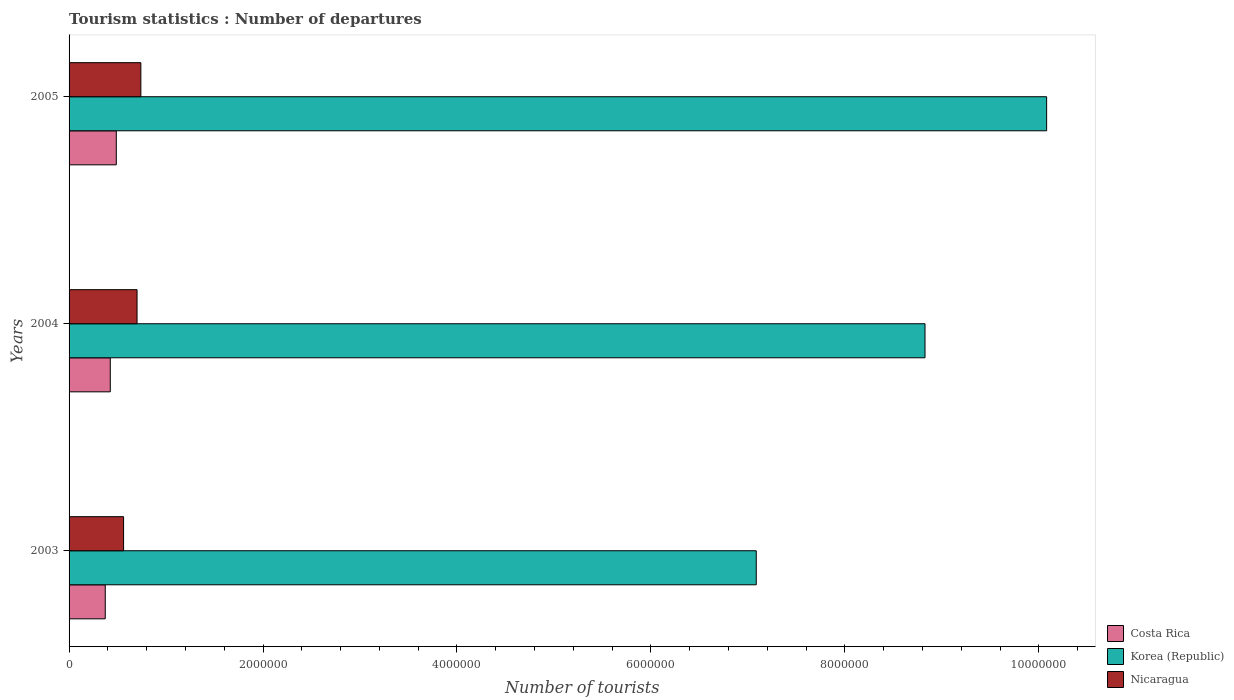Are the number of bars per tick equal to the number of legend labels?
Your response must be concise. Yes. How many bars are there on the 3rd tick from the top?
Your response must be concise. 3. How many bars are there on the 1st tick from the bottom?
Your response must be concise. 3. What is the number of tourist departures in Nicaragua in 2003?
Your answer should be very brief. 5.62e+05. Across all years, what is the maximum number of tourist departures in Costa Rica?
Provide a short and direct response. 4.87e+05. Across all years, what is the minimum number of tourist departures in Costa Rica?
Provide a short and direct response. 3.73e+05. In which year was the number of tourist departures in Costa Rica maximum?
Make the answer very short. 2005. In which year was the number of tourist departures in Nicaragua minimum?
Your answer should be compact. 2003. What is the total number of tourist departures in Nicaragua in the graph?
Ensure brevity in your answer.  2.00e+06. What is the difference between the number of tourist departures in Korea (Republic) in 2003 and that in 2005?
Make the answer very short. -2.99e+06. What is the difference between the number of tourist departures in Nicaragua in 2004 and the number of tourist departures in Korea (Republic) in 2003?
Offer a terse response. -6.38e+06. What is the average number of tourist departures in Costa Rica per year?
Ensure brevity in your answer.  4.28e+05. In the year 2005, what is the difference between the number of tourist departures in Nicaragua and number of tourist departures in Korea (Republic)?
Make the answer very short. -9.34e+06. In how many years, is the number of tourist departures in Costa Rica greater than 8800000 ?
Provide a succinct answer. 0. What is the ratio of the number of tourist departures in Nicaragua in 2003 to that in 2004?
Give a very brief answer. 0.8. What is the difference between the highest and the second highest number of tourist departures in Costa Rica?
Provide a short and direct response. 6.20e+04. What is the difference between the highest and the lowest number of tourist departures in Nicaragua?
Your answer should be very brief. 1.78e+05. In how many years, is the number of tourist departures in Korea (Republic) greater than the average number of tourist departures in Korea (Republic) taken over all years?
Give a very brief answer. 2. Is the sum of the number of tourist departures in Korea (Republic) in 2003 and 2005 greater than the maximum number of tourist departures in Nicaragua across all years?
Your answer should be compact. Yes. Is it the case that in every year, the sum of the number of tourist departures in Nicaragua and number of tourist departures in Korea (Republic) is greater than the number of tourist departures in Costa Rica?
Your answer should be very brief. Yes. Are all the bars in the graph horizontal?
Your answer should be very brief. Yes. How many years are there in the graph?
Keep it short and to the point. 3. What is the difference between two consecutive major ticks on the X-axis?
Offer a terse response. 2.00e+06. Does the graph contain any zero values?
Keep it short and to the point. No. Where does the legend appear in the graph?
Keep it short and to the point. Bottom right. How are the legend labels stacked?
Keep it short and to the point. Vertical. What is the title of the graph?
Offer a very short reply. Tourism statistics : Number of departures. Does "St. Vincent and the Grenadines" appear as one of the legend labels in the graph?
Offer a very short reply. No. What is the label or title of the X-axis?
Your answer should be very brief. Number of tourists. What is the Number of tourists of Costa Rica in 2003?
Your answer should be very brief. 3.73e+05. What is the Number of tourists in Korea (Republic) in 2003?
Offer a very short reply. 7.09e+06. What is the Number of tourists in Nicaragua in 2003?
Your answer should be very brief. 5.62e+05. What is the Number of tourists in Costa Rica in 2004?
Your answer should be very brief. 4.25e+05. What is the Number of tourists in Korea (Republic) in 2004?
Make the answer very short. 8.83e+06. What is the Number of tourists of Nicaragua in 2004?
Provide a succinct answer. 7.01e+05. What is the Number of tourists in Costa Rica in 2005?
Offer a very short reply. 4.87e+05. What is the Number of tourists in Korea (Republic) in 2005?
Offer a very short reply. 1.01e+07. What is the Number of tourists of Nicaragua in 2005?
Ensure brevity in your answer.  7.40e+05. Across all years, what is the maximum Number of tourists in Costa Rica?
Give a very brief answer. 4.87e+05. Across all years, what is the maximum Number of tourists in Korea (Republic)?
Provide a short and direct response. 1.01e+07. Across all years, what is the maximum Number of tourists in Nicaragua?
Give a very brief answer. 7.40e+05. Across all years, what is the minimum Number of tourists of Costa Rica?
Your answer should be compact. 3.73e+05. Across all years, what is the minimum Number of tourists in Korea (Republic)?
Offer a terse response. 7.09e+06. Across all years, what is the minimum Number of tourists of Nicaragua?
Keep it short and to the point. 5.62e+05. What is the total Number of tourists of Costa Rica in the graph?
Give a very brief answer. 1.28e+06. What is the total Number of tourists in Korea (Republic) in the graph?
Provide a succinct answer. 2.60e+07. What is the total Number of tourists of Nicaragua in the graph?
Your response must be concise. 2.00e+06. What is the difference between the Number of tourists of Costa Rica in 2003 and that in 2004?
Keep it short and to the point. -5.20e+04. What is the difference between the Number of tourists in Korea (Republic) in 2003 and that in 2004?
Offer a very short reply. -1.74e+06. What is the difference between the Number of tourists of Nicaragua in 2003 and that in 2004?
Your response must be concise. -1.39e+05. What is the difference between the Number of tourists in Costa Rica in 2003 and that in 2005?
Offer a terse response. -1.14e+05. What is the difference between the Number of tourists of Korea (Republic) in 2003 and that in 2005?
Provide a succinct answer. -2.99e+06. What is the difference between the Number of tourists of Nicaragua in 2003 and that in 2005?
Make the answer very short. -1.78e+05. What is the difference between the Number of tourists of Costa Rica in 2004 and that in 2005?
Make the answer very short. -6.20e+04. What is the difference between the Number of tourists of Korea (Republic) in 2004 and that in 2005?
Provide a short and direct response. -1.25e+06. What is the difference between the Number of tourists in Nicaragua in 2004 and that in 2005?
Provide a succinct answer. -3.90e+04. What is the difference between the Number of tourists of Costa Rica in 2003 and the Number of tourists of Korea (Republic) in 2004?
Your answer should be compact. -8.45e+06. What is the difference between the Number of tourists in Costa Rica in 2003 and the Number of tourists in Nicaragua in 2004?
Offer a very short reply. -3.28e+05. What is the difference between the Number of tourists in Korea (Republic) in 2003 and the Number of tourists in Nicaragua in 2004?
Offer a very short reply. 6.38e+06. What is the difference between the Number of tourists in Costa Rica in 2003 and the Number of tourists in Korea (Republic) in 2005?
Keep it short and to the point. -9.71e+06. What is the difference between the Number of tourists of Costa Rica in 2003 and the Number of tourists of Nicaragua in 2005?
Your answer should be very brief. -3.67e+05. What is the difference between the Number of tourists of Korea (Republic) in 2003 and the Number of tourists of Nicaragua in 2005?
Your response must be concise. 6.35e+06. What is the difference between the Number of tourists in Costa Rica in 2004 and the Number of tourists in Korea (Republic) in 2005?
Offer a very short reply. -9.66e+06. What is the difference between the Number of tourists of Costa Rica in 2004 and the Number of tourists of Nicaragua in 2005?
Your answer should be very brief. -3.15e+05. What is the difference between the Number of tourists in Korea (Republic) in 2004 and the Number of tourists in Nicaragua in 2005?
Provide a succinct answer. 8.09e+06. What is the average Number of tourists in Costa Rica per year?
Provide a short and direct response. 4.28e+05. What is the average Number of tourists in Korea (Republic) per year?
Ensure brevity in your answer.  8.66e+06. What is the average Number of tourists in Nicaragua per year?
Offer a terse response. 6.68e+05. In the year 2003, what is the difference between the Number of tourists in Costa Rica and Number of tourists in Korea (Republic)?
Make the answer very short. -6.71e+06. In the year 2003, what is the difference between the Number of tourists of Costa Rica and Number of tourists of Nicaragua?
Provide a short and direct response. -1.89e+05. In the year 2003, what is the difference between the Number of tourists of Korea (Republic) and Number of tourists of Nicaragua?
Make the answer very short. 6.52e+06. In the year 2004, what is the difference between the Number of tourists of Costa Rica and Number of tourists of Korea (Republic)?
Make the answer very short. -8.40e+06. In the year 2004, what is the difference between the Number of tourists in Costa Rica and Number of tourists in Nicaragua?
Offer a very short reply. -2.76e+05. In the year 2004, what is the difference between the Number of tourists in Korea (Republic) and Number of tourists in Nicaragua?
Make the answer very short. 8.12e+06. In the year 2005, what is the difference between the Number of tourists of Costa Rica and Number of tourists of Korea (Republic)?
Provide a succinct answer. -9.59e+06. In the year 2005, what is the difference between the Number of tourists in Costa Rica and Number of tourists in Nicaragua?
Offer a terse response. -2.53e+05. In the year 2005, what is the difference between the Number of tourists in Korea (Republic) and Number of tourists in Nicaragua?
Make the answer very short. 9.34e+06. What is the ratio of the Number of tourists of Costa Rica in 2003 to that in 2004?
Your answer should be compact. 0.88. What is the ratio of the Number of tourists of Korea (Republic) in 2003 to that in 2004?
Keep it short and to the point. 0.8. What is the ratio of the Number of tourists of Nicaragua in 2003 to that in 2004?
Give a very brief answer. 0.8. What is the ratio of the Number of tourists in Costa Rica in 2003 to that in 2005?
Your answer should be compact. 0.77. What is the ratio of the Number of tourists of Korea (Republic) in 2003 to that in 2005?
Provide a succinct answer. 0.7. What is the ratio of the Number of tourists in Nicaragua in 2003 to that in 2005?
Ensure brevity in your answer.  0.76. What is the ratio of the Number of tourists in Costa Rica in 2004 to that in 2005?
Offer a terse response. 0.87. What is the ratio of the Number of tourists in Korea (Republic) in 2004 to that in 2005?
Give a very brief answer. 0.88. What is the ratio of the Number of tourists in Nicaragua in 2004 to that in 2005?
Ensure brevity in your answer.  0.95. What is the difference between the highest and the second highest Number of tourists of Costa Rica?
Keep it short and to the point. 6.20e+04. What is the difference between the highest and the second highest Number of tourists in Korea (Republic)?
Ensure brevity in your answer.  1.25e+06. What is the difference between the highest and the second highest Number of tourists in Nicaragua?
Ensure brevity in your answer.  3.90e+04. What is the difference between the highest and the lowest Number of tourists of Costa Rica?
Provide a succinct answer. 1.14e+05. What is the difference between the highest and the lowest Number of tourists of Korea (Republic)?
Provide a short and direct response. 2.99e+06. What is the difference between the highest and the lowest Number of tourists of Nicaragua?
Keep it short and to the point. 1.78e+05. 